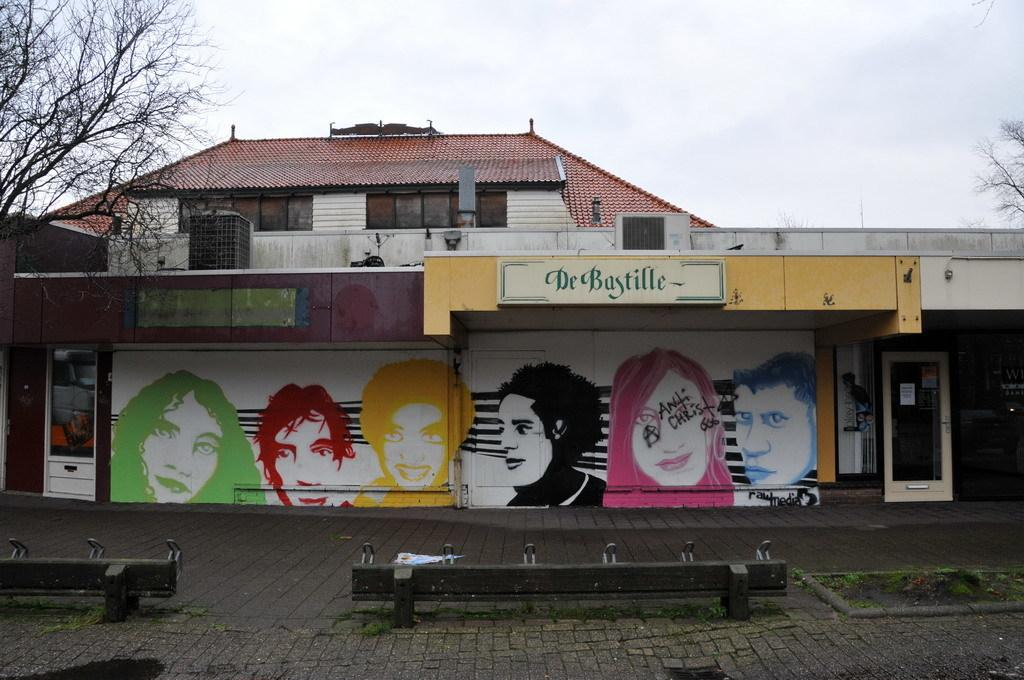What type of structure is visible in the image? There is a house in the image. What features can be seen on the house? The house has windows. What type of vegetation is present in the image? There are trees and grass in the image. What type of path is visible in the image? There is a footpath in the image. What part of the natural environment is visible in the image? The sky is visible in the image. How many giants are visible in the image? There are no giants present in the image. What type of hydrant is located near the house in the image? There is no hydrant present in the image. 